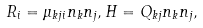Convert formula to latex. <formula><loc_0><loc_0><loc_500><loc_500>R _ { i } = \mu _ { k j i } n _ { k } n _ { j } , H = Q _ { k j } n _ { k } n _ { j } ,</formula> 